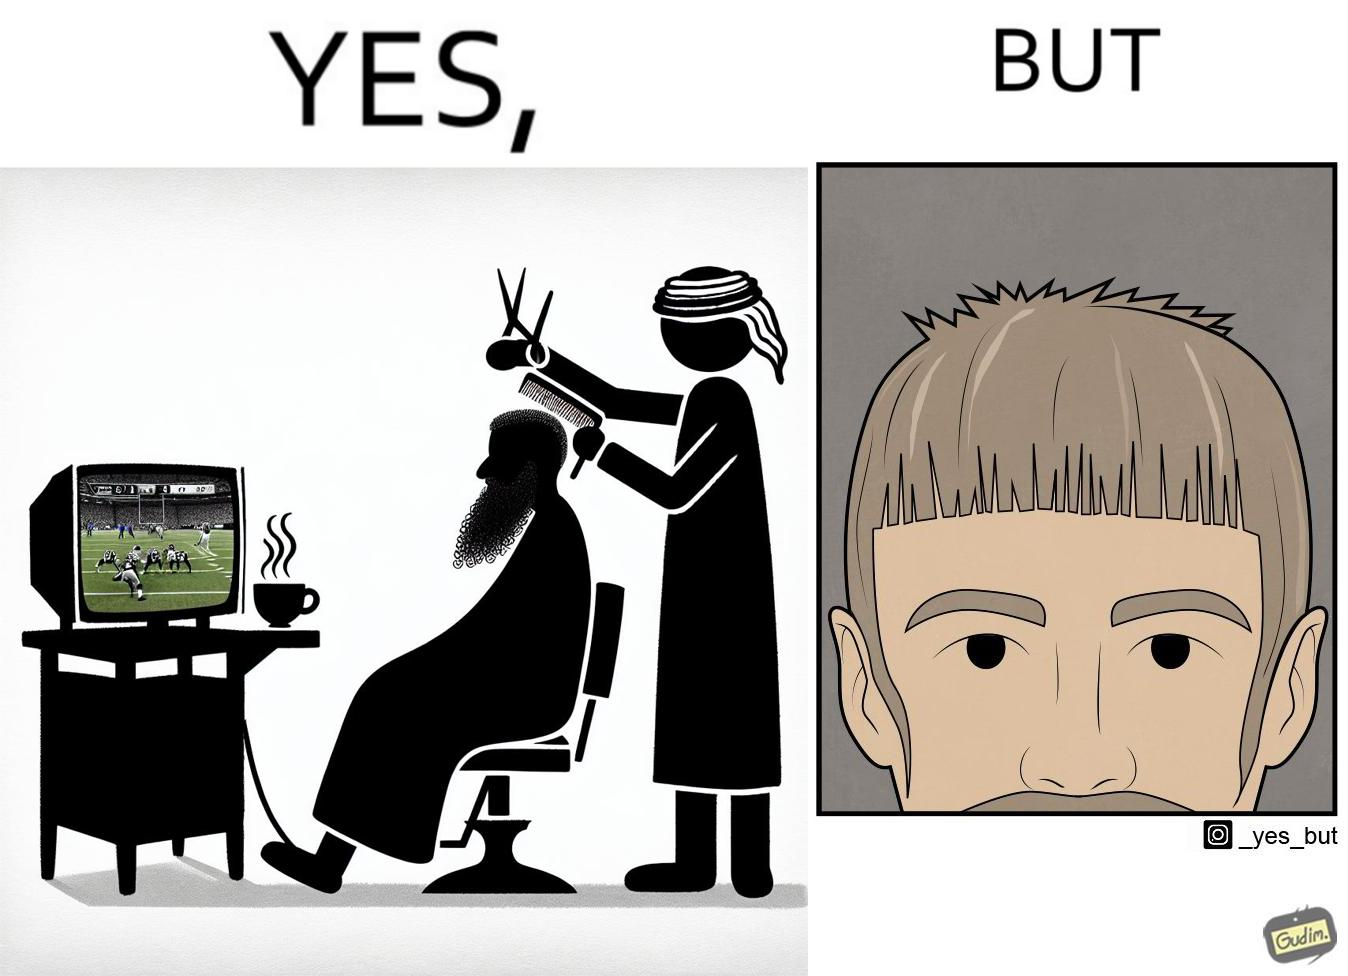Does this image contain satire or humor? Yes, this image is satirical. 